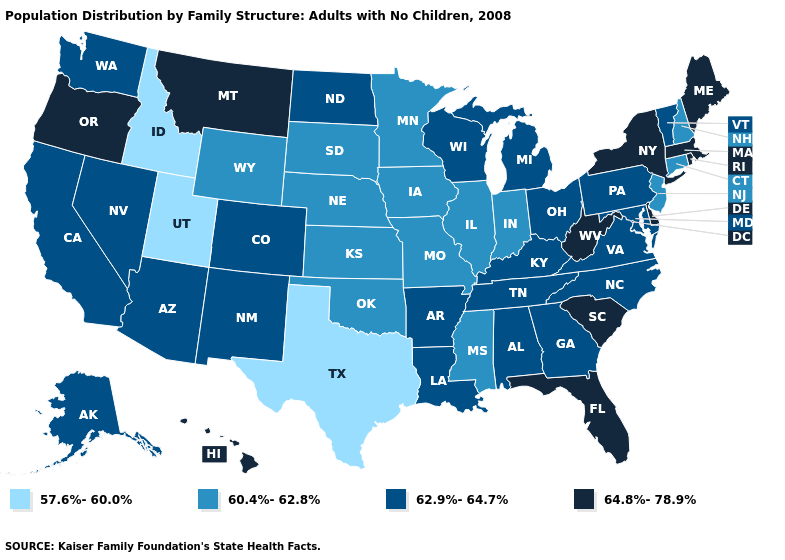Name the states that have a value in the range 60.4%-62.8%?
Give a very brief answer. Connecticut, Illinois, Indiana, Iowa, Kansas, Minnesota, Mississippi, Missouri, Nebraska, New Hampshire, New Jersey, Oklahoma, South Dakota, Wyoming. Name the states that have a value in the range 64.8%-78.9%?
Short answer required. Delaware, Florida, Hawaii, Maine, Massachusetts, Montana, New York, Oregon, Rhode Island, South Carolina, West Virginia. Which states hav the highest value in the South?
Concise answer only. Delaware, Florida, South Carolina, West Virginia. Which states hav the highest value in the Northeast?
Give a very brief answer. Maine, Massachusetts, New York, Rhode Island. Does Oklahoma have the lowest value in the South?
Quick response, please. No. What is the lowest value in the USA?
Write a very short answer. 57.6%-60.0%. Does Utah have the lowest value in the USA?
Give a very brief answer. Yes. Which states hav the highest value in the West?
Concise answer only. Hawaii, Montana, Oregon. Name the states that have a value in the range 57.6%-60.0%?
Quick response, please. Idaho, Texas, Utah. What is the highest value in states that border New Mexico?
Short answer required. 62.9%-64.7%. Which states hav the highest value in the West?
Short answer required. Hawaii, Montana, Oregon. Among the states that border Maine , which have the highest value?
Short answer required. New Hampshire. What is the lowest value in the West?
Answer briefly. 57.6%-60.0%. Name the states that have a value in the range 62.9%-64.7%?
Be succinct. Alabama, Alaska, Arizona, Arkansas, California, Colorado, Georgia, Kentucky, Louisiana, Maryland, Michigan, Nevada, New Mexico, North Carolina, North Dakota, Ohio, Pennsylvania, Tennessee, Vermont, Virginia, Washington, Wisconsin. Does Colorado have a higher value than Utah?
Be succinct. Yes. 